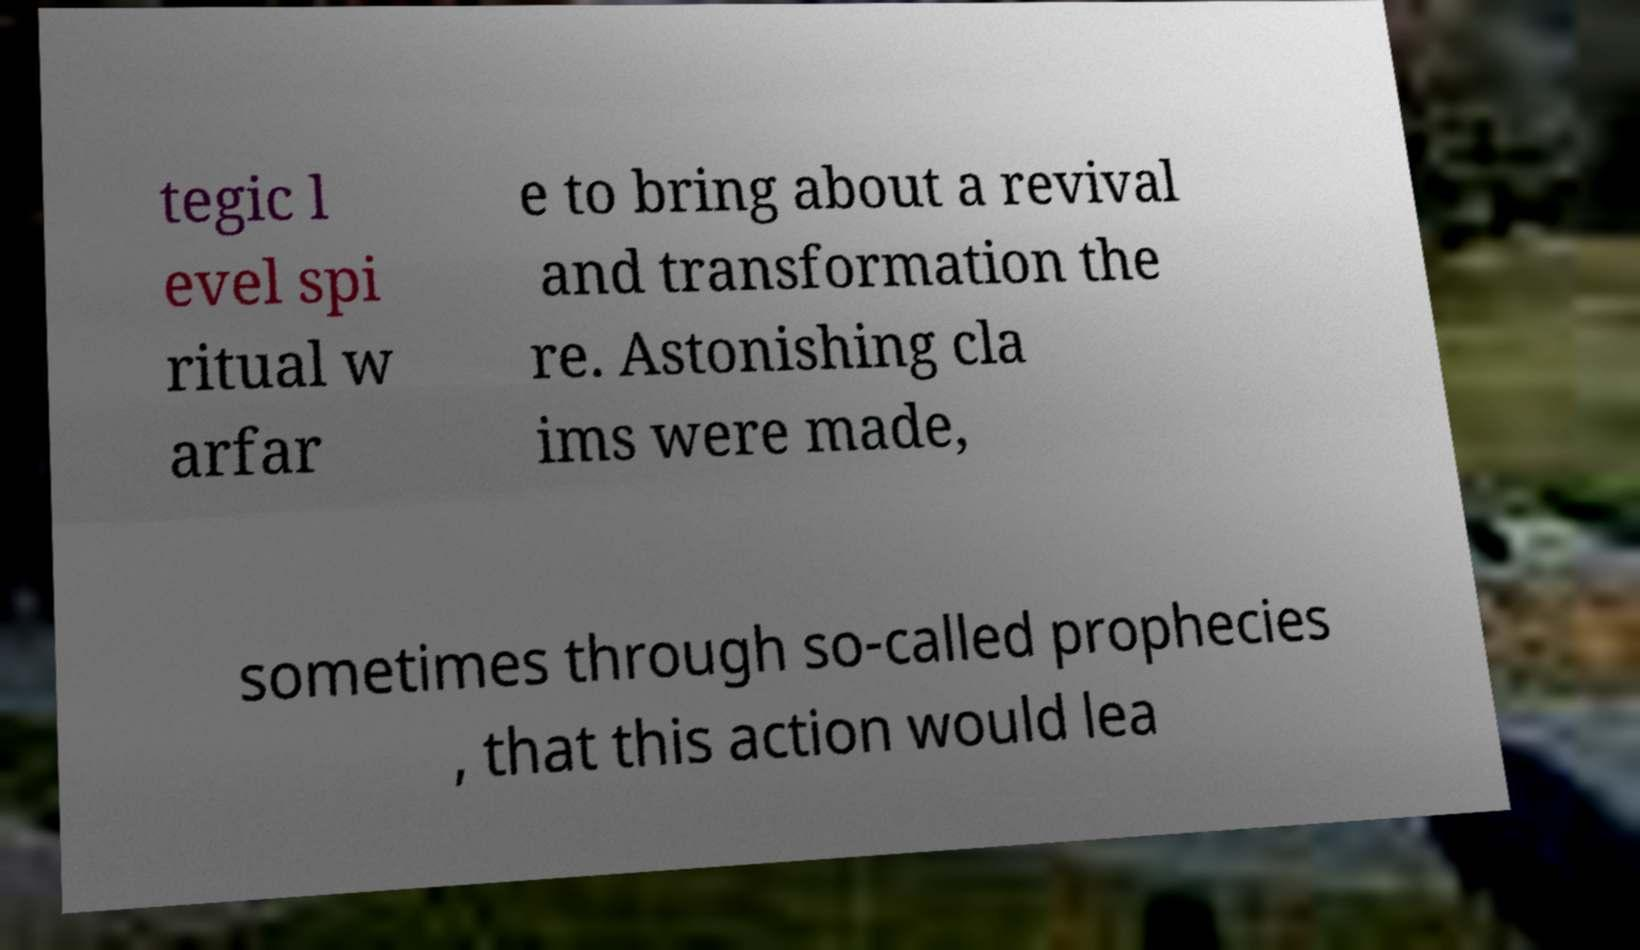Please read and relay the text visible in this image. What does it say? tegic l evel spi ritual w arfar e to bring about a revival and transformation the re. Astonishing cla ims were made, sometimes through so-called prophecies , that this action would lea 